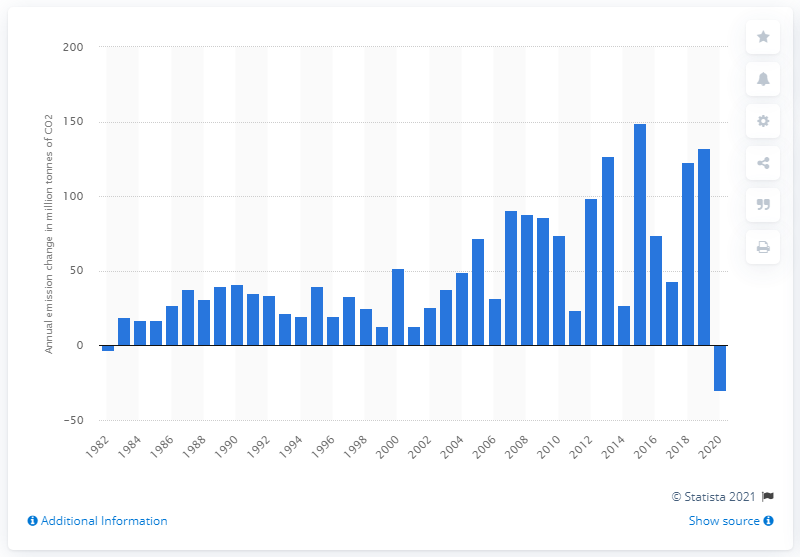Mention a couple of crucial points in this snapshot. In the year 1982, India's CO2 emissions decreased by three million metric tons of CO2. 